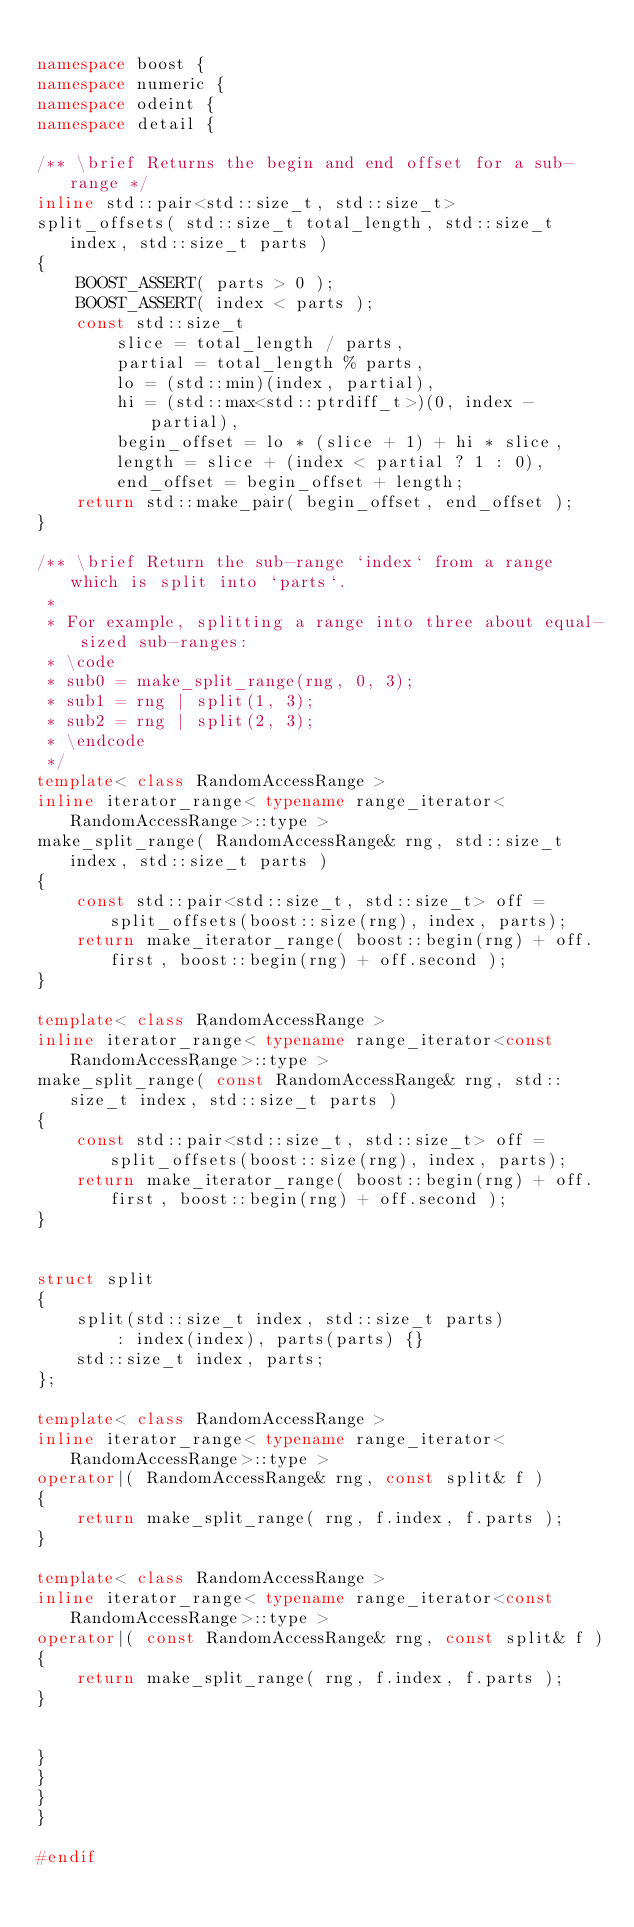Convert code to text. <code><loc_0><loc_0><loc_500><loc_500><_C++_>
namespace boost {
namespace numeric {
namespace odeint {
namespace detail {

/** \brief Returns the begin and end offset for a sub-range */
inline std::pair<std::size_t, std::size_t>
split_offsets( std::size_t total_length, std::size_t index, std::size_t parts )
{
    BOOST_ASSERT( parts > 0 );
    BOOST_ASSERT( index < parts );
    const std::size_t
        slice = total_length / parts,
        partial = total_length % parts,
        lo = (std::min)(index, partial),
        hi = (std::max<std::ptrdiff_t>)(0, index - partial),
        begin_offset = lo * (slice + 1) + hi * slice,
        length = slice + (index < partial ? 1 : 0),
        end_offset = begin_offset + length;
    return std::make_pair( begin_offset, end_offset );
}

/** \brief Return the sub-range `index` from a range which is split into `parts`.
 *
 * For example, splitting a range into three about equal-sized sub-ranges:
 * \code
 * sub0 = make_split_range(rng, 0, 3);
 * sub1 = rng | split(1, 3);
 * sub2 = rng | split(2, 3);
 * \endcode
 */
template< class RandomAccessRange >
inline iterator_range< typename range_iterator<RandomAccessRange>::type >
make_split_range( RandomAccessRange& rng, std::size_t index, std::size_t parts )
{
    const std::pair<std::size_t, std::size_t> off = split_offsets(boost::size(rng), index, parts);
    return make_iterator_range( boost::begin(rng) + off.first, boost::begin(rng) + off.second );
}

template< class RandomAccessRange >
inline iterator_range< typename range_iterator<const RandomAccessRange>::type >
make_split_range( const RandomAccessRange& rng, std::size_t index, std::size_t parts )
{
    const std::pair<std::size_t, std::size_t> off = split_offsets(boost::size(rng), index, parts);
    return make_iterator_range( boost::begin(rng) + off.first, boost::begin(rng) + off.second );
}


struct split
{
    split(std::size_t index, std::size_t parts)
        : index(index), parts(parts) {}
    std::size_t index, parts;
};

template< class RandomAccessRange >
inline iterator_range< typename range_iterator<RandomAccessRange>::type >
operator|( RandomAccessRange& rng, const split& f )
{
    return make_split_range( rng, f.index, f.parts );
}

template< class RandomAccessRange >
inline iterator_range< typename range_iterator<const RandomAccessRange>::type >
operator|( const RandomAccessRange& rng, const split& f )
{
    return make_split_range( rng, f.index, f.parts );
}


}
}
}
}

#endif
</code> 